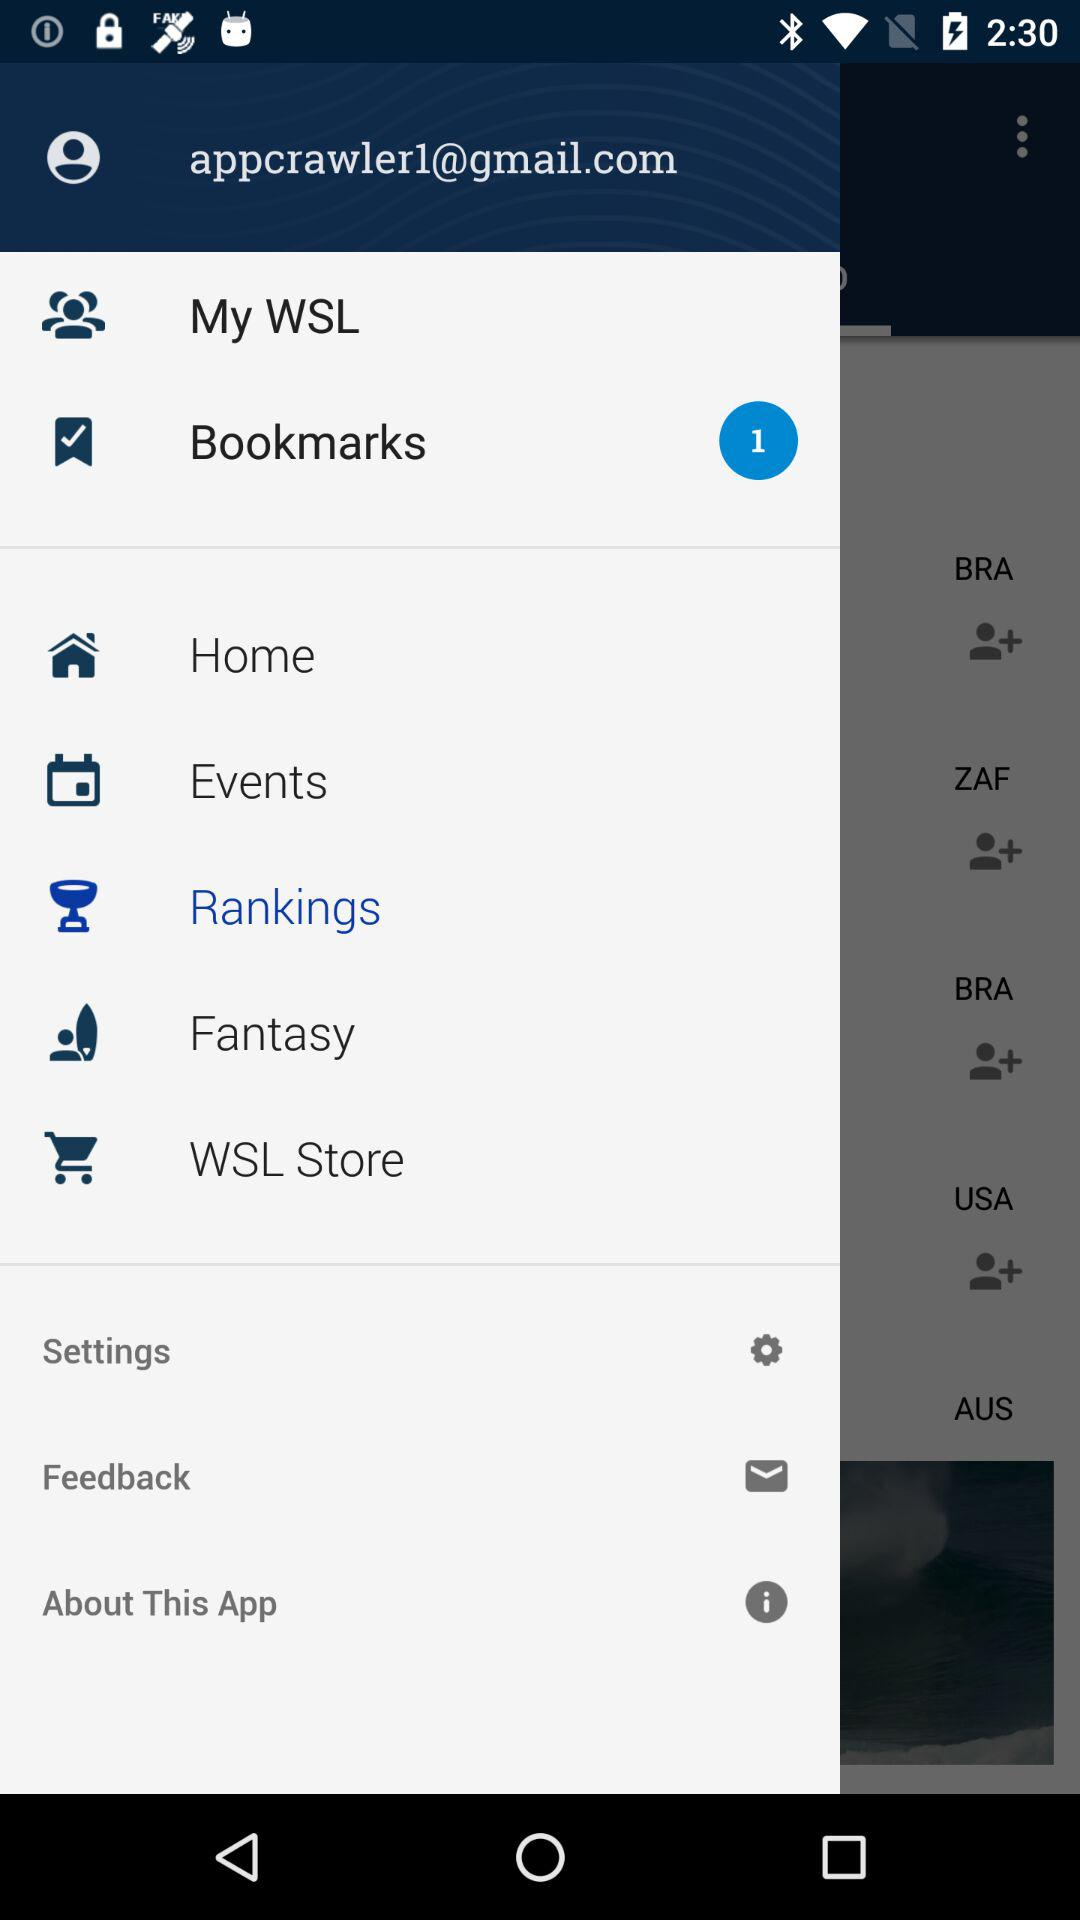What's the email address? The email address is appcrawler1@gmail.com. 